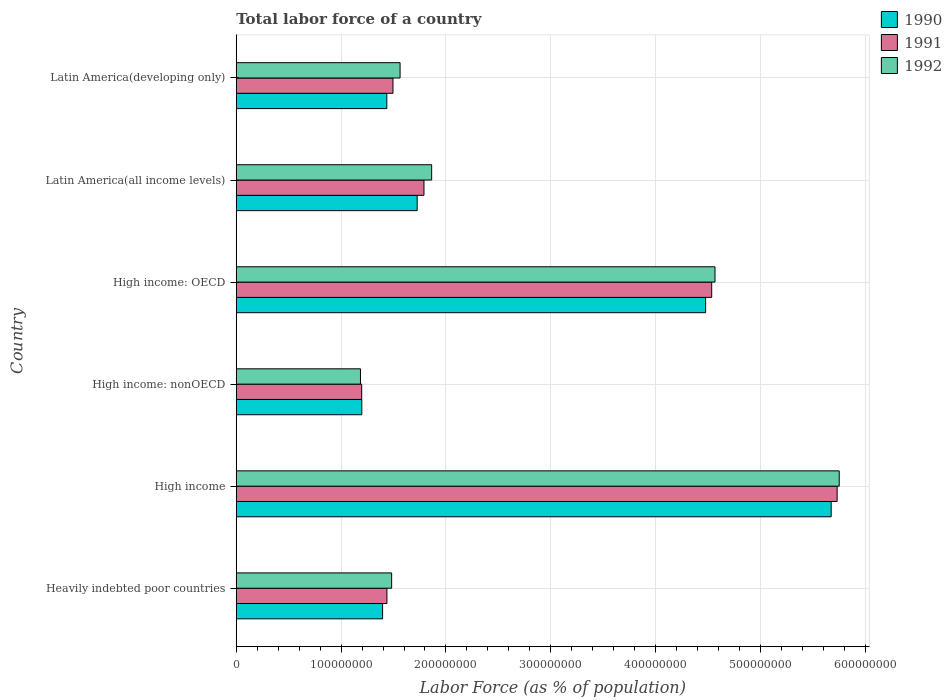How many bars are there on the 6th tick from the bottom?
Provide a short and direct response. 3. What is the label of the 3rd group of bars from the top?
Offer a very short reply. High income: OECD. In how many cases, is the number of bars for a given country not equal to the number of legend labels?
Your answer should be very brief. 0. What is the percentage of labor force in 1991 in Latin America(developing only)?
Offer a terse response. 1.49e+08. Across all countries, what is the maximum percentage of labor force in 1991?
Give a very brief answer. 5.73e+08. Across all countries, what is the minimum percentage of labor force in 1990?
Your response must be concise. 1.20e+08. In which country was the percentage of labor force in 1992 maximum?
Offer a terse response. High income. In which country was the percentage of labor force in 1992 minimum?
Provide a succinct answer. High income: nonOECD. What is the total percentage of labor force in 1992 in the graph?
Offer a terse response. 1.64e+09. What is the difference between the percentage of labor force in 1990 in Heavily indebted poor countries and that in Latin America(developing only)?
Your answer should be very brief. -4.01e+06. What is the difference between the percentage of labor force in 1990 in Heavily indebted poor countries and the percentage of labor force in 1991 in Latin America(all income levels)?
Provide a short and direct response. -3.95e+07. What is the average percentage of labor force in 1992 per country?
Make the answer very short. 2.74e+08. What is the difference between the percentage of labor force in 1991 and percentage of labor force in 1992 in High income: OECD?
Provide a short and direct response. -3.15e+06. In how many countries, is the percentage of labor force in 1992 greater than 100000000 %?
Provide a succinct answer. 6. What is the ratio of the percentage of labor force in 1990 in Heavily indebted poor countries to that in High income?
Keep it short and to the point. 0.25. What is the difference between the highest and the second highest percentage of labor force in 1992?
Offer a very short reply. 1.18e+08. What is the difference between the highest and the lowest percentage of labor force in 1992?
Offer a terse response. 4.57e+08. In how many countries, is the percentage of labor force in 1990 greater than the average percentage of labor force in 1990 taken over all countries?
Offer a very short reply. 2. What does the 1st bar from the top in Latin America(all income levels) represents?
Keep it short and to the point. 1992. Are all the bars in the graph horizontal?
Keep it short and to the point. Yes. How many countries are there in the graph?
Offer a terse response. 6. Does the graph contain grids?
Keep it short and to the point. Yes. How are the legend labels stacked?
Your answer should be compact. Vertical. What is the title of the graph?
Offer a very short reply. Total labor force of a country. What is the label or title of the X-axis?
Your answer should be very brief. Labor Force (as % of population). What is the label or title of the Y-axis?
Ensure brevity in your answer.  Country. What is the Labor Force (as % of population) of 1990 in Heavily indebted poor countries?
Offer a terse response. 1.40e+08. What is the Labor Force (as % of population) of 1991 in Heavily indebted poor countries?
Your answer should be compact. 1.44e+08. What is the Labor Force (as % of population) in 1992 in Heavily indebted poor countries?
Your answer should be very brief. 1.48e+08. What is the Labor Force (as % of population) in 1990 in High income?
Your answer should be very brief. 5.67e+08. What is the Labor Force (as % of population) of 1991 in High income?
Offer a very short reply. 5.73e+08. What is the Labor Force (as % of population) of 1992 in High income?
Offer a very short reply. 5.75e+08. What is the Labor Force (as % of population) in 1990 in High income: nonOECD?
Your answer should be compact. 1.20e+08. What is the Labor Force (as % of population) in 1991 in High income: nonOECD?
Give a very brief answer. 1.20e+08. What is the Labor Force (as % of population) in 1992 in High income: nonOECD?
Ensure brevity in your answer.  1.18e+08. What is the Labor Force (as % of population) in 1990 in High income: OECD?
Keep it short and to the point. 4.48e+08. What is the Labor Force (as % of population) of 1991 in High income: OECD?
Give a very brief answer. 4.53e+08. What is the Labor Force (as % of population) of 1992 in High income: OECD?
Offer a terse response. 4.57e+08. What is the Labor Force (as % of population) of 1990 in Latin America(all income levels)?
Ensure brevity in your answer.  1.73e+08. What is the Labor Force (as % of population) in 1991 in Latin America(all income levels)?
Your answer should be compact. 1.79e+08. What is the Labor Force (as % of population) of 1992 in Latin America(all income levels)?
Provide a succinct answer. 1.86e+08. What is the Labor Force (as % of population) of 1990 in Latin America(developing only)?
Your answer should be very brief. 1.44e+08. What is the Labor Force (as % of population) in 1991 in Latin America(developing only)?
Provide a short and direct response. 1.49e+08. What is the Labor Force (as % of population) in 1992 in Latin America(developing only)?
Offer a terse response. 1.56e+08. Across all countries, what is the maximum Labor Force (as % of population) of 1990?
Your response must be concise. 5.67e+08. Across all countries, what is the maximum Labor Force (as % of population) of 1991?
Your answer should be compact. 5.73e+08. Across all countries, what is the maximum Labor Force (as % of population) of 1992?
Your answer should be very brief. 5.75e+08. Across all countries, what is the minimum Labor Force (as % of population) in 1990?
Ensure brevity in your answer.  1.20e+08. Across all countries, what is the minimum Labor Force (as % of population) in 1991?
Your answer should be compact. 1.20e+08. Across all countries, what is the minimum Labor Force (as % of population) in 1992?
Provide a succinct answer. 1.18e+08. What is the total Labor Force (as % of population) of 1990 in the graph?
Ensure brevity in your answer.  1.59e+09. What is the total Labor Force (as % of population) of 1991 in the graph?
Ensure brevity in your answer.  1.62e+09. What is the total Labor Force (as % of population) of 1992 in the graph?
Offer a terse response. 1.64e+09. What is the difference between the Labor Force (as % of population) in 1990 in Heavily indebted poor countries and that in High income?
Your answer should be very brief. -4.28e+08. What is the difference between the Labor Force (as % of population) in 1991 in Heavily indebted poor countries and that in High income?
Offer a very short reply. -4.29e+08. What is the difference between the Labor Force (as % of population) of 1992 in Heavily indebted poor countries and that in High income?
Provide a short and direct response. -4.27e+08. What is the difference between the Labor Force (as % of population) of 1990 in Heavily indebted poor countries and that in High income: nonOECD?
Offer a very short reply. 1.98e+07. What is the difference between the Labor Force (as % of population) of 1991 in Heavily indebted poor countries and that in High income: nonOECD?
Give a very brief answer. 2.41e+07. What is the difference between the Labor Force (as % of population) of 1992 in Heavily indebted poor countries and that in High income: nonOECD?
Provide a succinct answer. 2.97e+07. What is the difference between the Labor Force (as % of population) in 1990 in Heavily indebted poor countries and that in High income: OECD?
Give a very brief answer. -3.08e+08. What is the difference between the Labor Force (as % of population) of 1991 in Heavily indebted poor countries and that in High income: OECD?
Keep it short and to the point. -3.10e+08. What is the difference between the Labor Force (as % of population) of 1992 in Heavily indebted poor countries and that in High income: OECD?
Your answer should be compact. -3.08e+08. What is the difference between the Labor Force (as % of population) of 1990 in Heavily indebted poor countries and that in Latin America(all income levels)?
Make the answer very short. -3.30e+07. What is the difference between the Labor Force (as % of population) of 1991 in Heavily indebted poor countries and that in Latin America(all income levels)?
Offer a terse response. -3.53e+07. What is the difference between the Labor Force (as % of population) of 1992 in Heavily indebted poor countries and that in Latin America(all income levels)?
Offer a terse response. -3.82e+07. What is the difference between the Labor Force (as % of population) in 1990 in Heavily indebted poor countries and that in Latin America(developing only)?
Ensure brevity in your answer.  -4.01e+06. What is the difference between the Labor Force (as % of population) in 1991 in Heavily indebted poor countries and that in Latin America(developing only)?
Offer a terse response. -5.77e+06. What is the difference between the Labor Force (as % of population) of 1992 in Heavily indebted poor countries and that in Latin America(developing only)?
Your answer should be compact. -8.04e+06. What is the difference between the Labor Force (as % of population) in 1990 in High income and that in High income: nonOECD?
Your answer should be very brief. 4.48e+08. What is the difference between the Labor Force (as % of population) of 1991 in High income and that in High income: nonOECD?
Ensure brevity in your answer.  4.53e+08. What is the difference between the Labor Force (as % of population) of 1992 in High income and that in High income: nonOECD?
Your response must be concise. 4.57e+08. What is the difference between the Labor Force (as % of population) of 1990 in High income and that in High income: OECD?
Your response must be concise. 1.20e+08. What is the difference between the Labor Force (as % of population) in 1991 in High income and that in High income: OECD?
Give a very brief answer. 1.20e+08. What is the difference between the Labor Force (as % of population) in 1992 in High income and that in High income: OECD?
Your answer should be compact. 1.18e+08. What is the difference between the Labor Force (as % of population) in 1990 in High income and that in Latin America(all income levels)?
Provide a short and direct response. 3.95e+08. What is the difference between the Labor Force (as % of population) in 1991 in High income and that in Latin America(all income levels)?
Offer a terse response. 3.94e+08. What is the difference between the Labor Force (as % of population) in 1992 in High income and that in Latin America(all income levels)?
Offer a very short reply. 3.89e+08. What is the difference between the Labor Force (as % of population) in 1990 in High income and that in Latin America(developing only)?
Provide a short and direct response. 4.24e+08. What is the difference between the Labor Force (as % of population) of 1991 in High income and that in Latin America(developing only)?
Keep it short and to the point. 4.24e+08. What is the difference between the Labor Force (as % of population) of 1992 in High income and that in Latin America(developing only)?
Make the answer very short. 4.19e+08. What is the difference between the Labor Force (as % of population) of 1990 in High income: nonOECD and that in High income: OECD?
Make the answer very short. -3.28e+08. What is the difference between the Labor Force (as % of population) in 1991 in High income: nonOECD and that in High income: OECD?
Provide a short and direct response. -3.34e+08. What is the difference between the Labor Force (as % of population) in 1992 in High income: nonOECD and that in High income: OECD?
Your answer should be compact. -3.38e+08. What is the difference between the Labor Force (as % of population) in 1990 in High income: nonOECD and that in Latin America(all income levels)?
Provide a succinct answer. -5.28e+07. What is the difference between the Labor Force (as % of population) of 1991 in High income: nonOECD and that in Latin America(all income levels)?
Offer a very short reply. -5.94e+07. What is the difference between the Labor Force (as % of population) in 1992 in High income: nonOECD and that in Latin America(all income levels)?
Offer a very short reply. -6.79e+07. What is the difference between the Labor Force (as % of population) in 1990 in High income: nonOECD and that in Latin America(developing only)?
Offer a terse response. -2.38e+07. What is the difference between the Labor Force (as % of population) of 1991 in High income: nonOECD and that in Latin America(developing only)?
Your answer should be compact. -2.98e+07. What is the difference between the Labor Force (as % of population) of 1992 in High income: nonOECD and that in Latin America(developing only)?
Provide a succinct answer. -3.78e+07. What is the difference between the Labor Force (as % of population) in 1990 in High income: OECD and that in Latin America(all income levels)?
Offer a terse response. 2.75e+08. What is the difference between the Labor Force (as % of population) of 1991 in High income: OECD and that in Latin America(all income levels)?
Provide a succinct answer. 2.74e+08. What is the difference between the Labor Force (as % of population) in 1992 in High income: OECD and that in Latin America(all income levels)?
Provide a succinct answer. 2.70e+08. What is the difference between the Labor Force (as % of population) of 1990 in High income: OECD and that in Latin America(developing only)?
Give a very brief answer. 3.04e+08. What is the difference between the Labor Force (as % of population) of 1991 in High income: OECD and that in Latin America(developing only)?
Your answer should be compact. 3.04e+08. What is the difference between the Labor Force (as % of population) in 1992 in High income: OECD and that in Latin America(developing only)?
Give a very brief answer. 3.00e+08. What is the difference between the Labor Force (as % of population) in 1990 in Latin America(all income levels) and that in Latin America(developing only)?
Provide a succinct answer. 2.90e+07. What is the difference between the Labor Force (as % of population) of 1991 in Latin America(all income levels) and that in Latin America(developing only)?
Your answer should be very brief. 2.96e+07. What is the difference between the Labor Force (as % of population) in 1992 in Latin America(all income levels) and that in Latin America(developing only)?
Keep it short and to the point. 3.01e+07. What is the difference between the Labor Force (as % of population) of 1990 in Heavily indebted poor countries and the Labor Force (as % of population) of 1991 in High income?
Your answer should be compact. -4.34e+08. What is the difference between the Labor Force (as % of population) of 1990 in Heavily indebted poor countries and the Labor Force (as % of population) of 1992 in High income?
Provide a succinct answer. -4.36e+08. What is the difference between the Labor Force (as % of population) in 1991 in Heavily indebted poor countries and the Labor Force (as % of population) in 1992 in High income?
Provide a short and direct response. -4.31e+08. What is the difference between the Labor Force (as % of population) in 1990 in Heavily indebted poor countries and the Labor Force (as % of population) in 1991 in High income: nonOECD?
Provide a short and direct response. 2.00e+07. What is the difference between the Labor Force (as % of population) of 1990 in Heavily indebted poor countries and the Labor Force (as % of population) of 1992 in High income: nonOECD?
Offer a terse response. 2.11e+07. What is the difference between the Labor Force (as % of population) in 1991 in Heavily indebted poor countries and the Labor Force (as % of population) in 1992 in High income: nonOECD?
Your answer should be compact. 2.52e+07. What is the difference between the Labor Force (as % of population) of 1990 in Heavily indebted poor countries and the Labor Force (as % of population) of 1991 in High income: OECD?
Ensure brevity in your answer.  -3.14e+08. What is the difference between the Labor Force (as % of population) in 1990 in Heavily indebted poor countries and the Labor Force (as % of population) in 1992 in High income: OECD?
Provide a succinct answer. -3.17e+08. What is the difference between the Labor Force (as % of population) of 1991 in Heavily indebted poor countries and the Labor Force (as % of population) of 1992 in High income: OECD?
Your response must be concise. -3.13e+08. What is the difference between the Labor Force (as % of population) in 1990 in Heavily indebted poor countries and the Labor Force (as % of population) in 1991 in Latin America(all income levels)?
Make the answer very short. -3.95e+07. What is the difference between the Labor Force (as % of population) of 1990 in Heavily indebted poor countries and the Labor Force (as % of population) of 1992 in Latin America(all income levels)?
Offer a terse response. -4.68e+07. What is the difference between the Labor Force (as % of population) in 1991 in Heavily indebted poor countries and the Labor Force (as % of population) in 1992 in Latin America(all income levels)?
Your answer should be compact. -4.27e+07. What is the difference between the Labor Force (as % of population) of 1990 in Heavily indebted poor countries and the Labor Force (as % of population) of 1991 in Latin America(developing only)?
Give a very brief answer. -9.89e+06. What is the difference between the Labor Force (as % of population) of 1990 in Heavily indebted poor countries and the Labor Force (as % of population) of 1992 in Latin America(developing only)?
Make the answer very short. -1.67e+07. What is the difference between the Labor Force (as % of population) in 1991 in Heavily indebted poor countries and the Labor Force (as % of population) in 1992 in Latin America(developing only)?
Your answer should be compact. -1.25e+07. What is the difference between the Labor Force (as % of population) in 1990 in High income and the Labor Force (as % of population) in 1991 in High income: nonOECD?
Provide a short and direct response. 4.48e+08. What is the difference between the Labor Force (as % of population) in 1990 in High income and the Labor Force (as % of population) in 1992 in High income: nonOECD?
Offer a very short reply. 4.49e+08. What is the difference between the Labor Force (as % of population) of 1991 in High income and the Labor Force (as % of population) of 1992 in High income: nonOECD?
Make the answer very short. 4.55e+08. What is the difference between the Labor Force (as % of population) of 1990 in High income and the Labor Force (as % of population) of 1991 in High income: OECD?
Keep it short and to the point. 1.14e+08. What is the difference between the Labor Force (as % of population) of 1990 in High income and the Labor Force (as % of population) of 1992 in High income: OECD?
Your answer should be very brief. 1.11e+08. What is the difference between the Labor Force (as % of population) in 1991 in High income and the Labor Force (as % of population) in 1992 in High income: OECD?
Keep it short and to the point. 1.16e+08. What is the difference between the Labor Force (as % of population) in 1990 in High income and the Labor Force (as % of population) in 1991 in Latin America(all income levels)?
Offer a terse response. 3.88e+08. What is the difference between the Labor Force (as % of population) of 1990 in High income and the Labor Force (as % of population) of 1992 in Latin America(all income levels)?
Give a very brief answer. 3.81e+08. What is the difference between the Labor Force (as % of population) of 1991 in High income and the Labor Force (as % of population) of 1992 in Latin America(all income levels)?
Offer a very short reply. 3.87e+08. What is the difference between the Labor Force (as % of population) of 1990 in High income and the Labor Force (as % of population) of 1991 in Latin America(developing only)?
Offer a terse response. 4.18e+08. What is the difference between the Labor Force (as % of population) in 1990 in High income and the Labor Force (as % of population) in 1992 in Latin America(developing only)?
Your response must be concise. 4.11e+08. What is the difference between the Labor Force (as % of population) in 1991 in High income and the Labor Force (as % of population) in 1992 in Latin America(developing only)?
Ensure brevity in your answer.  4.17e+08. What is the difference between the Labor Force (as % of population) in 1990 in High income: nonOECD and the Labor Force (as % of population) in 1991 in High income: OECD?
Make the answer very short. -3.34e+08. What is the difference between the Labor Force (as % of population) of 1990 in High income: nonOECD and the Labor Force (as % of population) of 1992 in High income: OECD?
Make the answer very short. -3.37e+08. What is the difference between the Labor Force (as % of population) in 1991 in High income: nonOECD and the Labor Force (as % of population) in 1992 in High income: OECD?
Your response must be concise. -3.37e+08. What is the difference between the Labor Force (as % of population) in 1990 in High income: nonOECD and the Labor Force (as % of population) in 1991 in Latin America(all income levels)?
Offer a very short reply. -5.93e+07. What is the difference between the Labor Force (as % of population) in 1990 in High income: nonOECD and the Labor Force (as % of population) in 1992 in Latin America(all income levels)?
Make the answer very short. -6.66e+07. What is the difference between the Labor Force (as % of population) of 1991 in High income: nonOECD and the Labor Force (as % of population) of 1992 in Latin America(all income levels)?
Provide a short and direct response. -6.67e+07. What is the difference between the Labor Force (as % of population) of 1990 in High income: nonOECD and the Labor Force (as % of population) of 1991 in Latin America(developing only)?
Ensure brevity in your answer.  -2.97e+07. What is the difference between the Labor Force (as % of population) in 1990 in High income: nonOECD and the Labor Force (as % of population) in 1992 in Latin America(developing only)?
Provide a short and direct response. -3.65e+07. What is the difference between the Labor Force (as % of population) in 1991 in High income: nonOECD and the Labor Force (as % of population) in 1992 in Latin America(developing only)?
Provide a short and direct response. -3.66e+07. What is the difference between the Labor Force (as % of population) in 1990 in High income: OECD and the Labor Force (as % of population) in 1991 in Latin America(all income levels)?
Your answer should be compact. 2.69e+08. What is the difference between the Labor Force (as % of population) of 1990 in High income: OECD and the Labor Force (as % of population) of 1992 in Latin America(all income levels)?
Offer a terse response. 2.61e+08. What is the difference between the Labor Force (as % of population) in 1991 in High income: OECD and the Labor Force (as % of population) in 1992 in Latin America(all income levels)?
Offer a terse response. 2.67e+08. What is the difference between the Labor Force (as % of population) in 1990 in High income: OECD and the Labor Force (as % of population) in 1991 in Latin America(developing only)?
Give a very brief answer. 2.98e+08. What is the difference between the Labor Force (as % of population) in 1990 in High income: OECD and the Labor Force (as % of population) in 1992 in Latin America(developing only)?
Provide a short and direct response. 2.91e+08. What is the difference between the Labor Force (as % of population) of 1991 in High income: OECD and the Labor Force (as % of population) of 1992 in Latin America(developing only)?
Give a very brief answer. 2.97e+08. What is the difference between the Labor Force (as % of population) in 1990 in Latin America(all income levels) and the Labor Force (as % of population) in 1991 in Latin America(developing only)?
Make the answer very short. 2.31e+07. What is the difference between the Labor Force (as % of population) of 1990 in Latin America(all income levels) and the Labor Force (as % of population) of 1992 in Latin America(developing only)?
Your response must be concise. 1.63e+07. What is the difference between the Labor Force (as % of population) of 1991 in Latin America(all income levels) and the Labor Force (as % of population) of 1992 in Latin America(developing only)?
Make the answer very short. 2.28e+07. What is the average Labor Force (as % of population) of 1990 per country?
Provide a succinct answer. 2.65e+08. What is the average Labor Force (as % of population) in 1991 per country?
Provide a short and direct response. 2.70e+08. What is the average Labor Force (as % of population) in 1992 per country?
Your answer should be very brief. 2.74e+08. What is the difference between the Labor Force (as % of population) in 1990 and Labor Force (as % of population) in 1991 in Heavily indebted poor countries?
Give a very brief answer. -4.12e+06. What is the difference between the Labor Force (as % of population) in 1990 and Labor Force (as % of population) in 1992 in Heavily indebted poor countries?
Provide a succinct answer. -8.62e+06. What is the difference between the Labor Force (as % of population) in 1991 and Labor Force (as % of population) in 1992 in Heavily indebted poor countries?
Offer a terse response. -4.50e+06. What is the difference between the Labor Force (as % of population) in 1990 and Labor Force (as % of population) in 1991 in High income?
Offer a very short reply. -5.67e+06. What is the difference between the Labor Force (as % of population) of 1990 and Labor Force (as % of population) of 1992 in High income?
Make the answer very short. -7.67e+06. What is the difference between the Labor Force (as % of population) of 1991 and Labor Force (as % of population) of 1992 in High income?
Ensure brevity in your answer.  -2.00e+06. What is the difference between the Labor Force (as % of population) in 1990 and Labor Force (as % of population) in 1991 in High income: nonOECD?
Keep it short and to the point. 1.23e+05. What is the difference between the Labor Force (as % of population) in 1990 and Labor Force (as % of population) in 1992 in High income: nonOECD?
Keep it short and to the point. 1.27e+06. What is the difference between the Labor Force (as % of population) in 1991 and Labor Force (as % of population) in 1992 in High income: nonOECD?
Your answer should be very brief. 1.15e+06. What is the difference between the Labor Force (as % of population) in 1990 and Labor Force (as % of population) in 1991 in High income: OECD?
Your response must be concise. -5.80e+06. What is the difference between the Labor Force (as % of population) in 1990 and Labor Force (as % of population) in 1992 in High income: OECD?
Your answer should be very brief. -8.94e+06. What is the difference between the Labor Force (as % of population) in 1991 and Labor Force (as % of population) in 1992 in High income: OECD?
Ensure brevity in your answer.  -3.15e+06. What is the difference between the Labor Force (as % of population) in 1990 and Labor Force (as % of population) in 1991 in Latin America(all income levels)?
Your answer should be compact. -6.48e+06. What is the difference between the Labor Force (as % of population) in 1990 and Labor Force (as % of population) in 1992 in Latin America(all income levels)?
Make the answer very short. -1.38e+07. What is the difference between the Labor Force (as % of population) in 1991 and Labor Force (as % of population) in 1992 in Latin America(all income levels)?
Your answer should be compact. -7.34e+06. What is the difference between the Labor Force (as % of population) in 1990 and Labor Force (as % of population) in 1991 in Latin America(developing only)?
Provide a succinct answer. -5.88e+06. What is the difference between the Labor Force (as % of population) of 1990 and Labor Force (as % of population) of 1992 in Latin America(developing only)?
Your answer should be very brief. -1.26e+07. What is the difference between the Labor Force (as % of population) of 1991 and Labor Force (as % of population) of 1992 in Latin America(developing only)?
Offer a terse response. -6.77e+06. What is the ratio of the Labor Force (as % of population) of 1990 in Heavily indebted poor countries to that in High income?
Keep it short and to the point. 0.25. What is the ratio of the Labor Force (as % of population) of 1991 in Heavily indebted poor countries to that in High income?
Offer a very short reply. 0.25. What is the ratio of the Labor Force (as % of population) of 1992 in Heavily indebted poor countries to that in High income?
Make the answer very short. 0.26. What is the ratio of the Labor Force (as % of population) in 1990 in Heavily indebted poor countries to that in High income: nonOECD?
Your response must be concise. 1.17. What is the ratio of the Labor Force (as % of population) of 1991 in Heavily indebted poor countries to that in High income: nonOECD?
Your answer should be very brief. 1.2. What is the ratio of the Labor Force (as % of population) in 1992 in Heavily indebted poor countries to that in High income: nonOECD?
Your response must be concise. 1.25. What is the ratio of the Labor Force (as % of population) of 1990 in Heavily indebted poor countries to that in High income: OECD?
Your answer should be very brief. 0.31. What is the ratio of the Labor Force (as % of population) of 1991 in Heavily indebted poor countries to that in High income: OECD?
Your answer should be very brief. 0.32. What is the ratio of the Labor Force (as % of population) in 1992 in Heavily indebted poor countries to that in High income: OECD?
Offer a very short reply. 0.32. What is the ratio of the Labor Force (as % of population) of 1990 in Heavily indebted poor countries to that in Latin America(all income levels)?
Give a very brief answer. 0.81. What is the ratio of the Labor Force (as % of population) of 1991 in Heavily indebted poor countries to that in Latin America(all income levels)?
Keep it short and to the point. 0.8. What is the ratio of the Labor Force (as % of population) in 1992 in Heavily indebted poor countries to that in Latin America(all income levels)?
Give a very brief answer. 0.8. What is the ratio of the Labor Force (as % of population) in 1990 in Heavily indebted poor countries to that in Latin America(developing only)?
Make the answer very short. 0.97. What is the ratio of the Labor Force (as % of population) in 1991 in Heavily indebted poor countries to that in Latin America(developing only)?
Make the answer very short. 0.96. What is the ratio of the Labor Force (as % of population) of 1992 in Heavily indebted poor countries to that in Latin America(developing only)?
Provide a succinct answer. 0.95. What is the ratio of the Labor Force (as % of population) of 1990 in High income to that in High income: nonOECD?
Give a very brief answer. 4.74. What is the ratio of the Labor Force (as % of population) in 1991 in High income to that in High income: nonOECD?
Your answer should be compact. 4.79. What is the ratio of the Labor Force (as % of population) of 1992 in High income to that in High income: nonOECD?
Your response must be concise. 4.85. What is the ratio of the Labor Force (as % of population) in 1990 in High income to that in High income: OECD?
Give a very brief answer. 1.27. What is the ratio of the Labor Force (as % of population) in 1991 in High income to that in High income: OECD?
Your response must be concise. 1.26. What is the ratio of the Labor Force (as % of population) in 1992 in High income to that in High income: OECD?
Your answer should be very brief. 1.26. What is the ratio of the Labor Force (as % of population) of 1990 in High income to that in Latin America(all income levels)?
Your answer should be compact. 3.29. What is the ratio of the Labor Force (as % of population) in 1991 in High income to that in Latin America(all income levels)?
Keep it short and to the point. 3.2. What is the ratio of the Labor Force (as % of population) of 1992 in High income to that in Latin America(all income levels)?
Make the answer very short. 3.09. What is the ratio of the Labor Force (as % of population) in 1990 in High income to that in Latin America(developing only)?
Provide a short and direct response. 3.95. What is the ratio of the Labor Force (as % of population) in 1991 in High income to that in Latin America(developing only)?
Your answer should be very brief. 3.83. What is the ratio of the Labor Force (as % of population) of 1992 in High income to that in Latin America(developing only)?
Your response must be concise. 3.68. What is the ratio of the Labor Force (as % of population) in 1990 in High income: nonOECD to that in High income: OECD?
Your answer should be very brief. 0.27. What is the ratio of the Labor Force (as % of population) of 1991 in High income: nonOECD to that in High income: OECD?
Keep it short and to the point. 0.26. What is the ratio of the Labor Force (as % of population) of 1992 in High income: nonOECD to that in High income: OECD?
Your response must be concise. 0.26. What is the ratio of the Labor Force (as % of population) of 1990 in High income: nonOECD to that in Latin America(all income levels)?
Ensure brevity in your answer.  0.69. What is the ratio of the Labor Force (as % of population) in 1991 in High income: nonOECD to that in Latin America(all income levels)?
Your response must be concise. 0.67. What is the ratio of the Labor Force (as % of population) in 1992 in High income: nonOECD to that in Latin America(all income levels)?
Provide a succinct answer. 0.64. What is the ratio of the Labor Force (as % of population) in 1990 in High income: nonOECD to that in Latin America(developing only)?
Your answer should be compact. 0.83. What is the ratio of the Labor Force (as % of population) of 1991 in High income: nonOECD to that in Latin America(developing only)?
Make the answer very short. 0.8. What is the ratio of the Labor Force (as % of population) in 1992 in High income: nonOECD to that in Latin America(developing only)?
Offer a very short reply. 0.76. What is the ratio of the Labor Force (as % of population) of 1990 in High income: OECD to that in Latin America(all income levels)?
Make the answer very short. 2.59. What is the ratio of the Labor Force (as % of population) of 1991 in High income: OECD to that in Latin America(all income levels)?
Ensure brevity in your answer.  2.53. What is the ratio of the Labor Force (as % of population) in 1992 in High income: OECD to that in Latin America(all income levels)?
Provide a succinct answer. 2.45. What is the ratio of the Labor Force (as % of population) in 1990 in High income: OECD to that in Latin America(developing only)?
Keep it short and to the point. 3.12. What is the ratio of the Labor Force (as % of population) in 1991 in High income: OECD to that in Latin America(developing only)?
Give a very brief answer. 3.03. What is the ratio of the Labor Force (as % of population) of 1992 in High income: OECD to that in Latin America(developing only)?
Give a very brief answer. 2.92. What is the ratio of the Labor Force (as % of population) of 1990 in Latin America(all income levels) to that in Latin America(developing only)?
Provide a short and direct response. 1.2. What is the ratio of the Labor Force (as % of population) in 1991 in Latin America(all income levels) to that in Latin America(developing only)?
Offer a very short reply. 1.2. What is the ratio of the Labor Force (as % of population) in 1992 in Latin America(all income levels) to that in Latin America(developing only)?
Your answer should be very brief. 1.19. What is the difference between the highest and the second highest Labor Force (as % of population) in 1990?
Give a very brief answer. 1.20e+08. What is the difference between the highest and the second highest Labor Force (as % of population) of 1991?
Ensure brevity in your answer.  1.20e+08. What is the difference between the highest and the second highest Labor Force (as % of population) of 1992?
Provide a short and direct response. 1.18e+08. What is the difference between the highest and the lowest Labor Force (as % of population) of 1990?
Ensure brevity in your answer.  4.48e+08. What is the difference between the highest and the lowest Labor Force (as % of population) of 1991?
Your answer should be very brief. 4.53e+08. What is the difference between the highest and the lowest Labor Force (as % of population) of 1992?
Provide a succinct answer. 4.57e+08. 